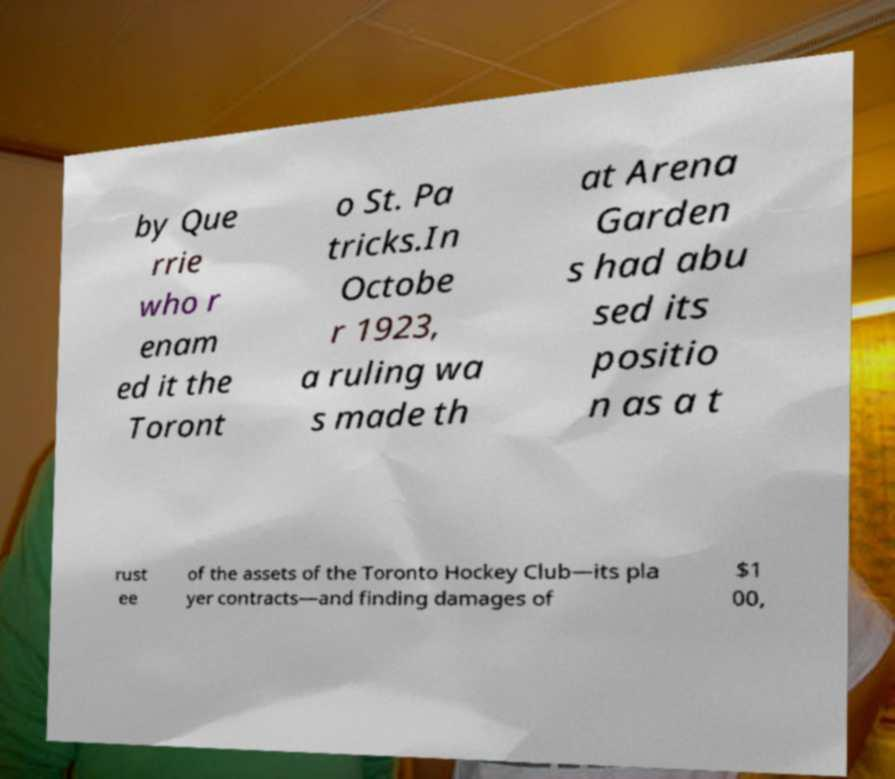What messages or text are displayed in this image? I need them in a readable, typed format. by Que rrie who r enam ed it the Toront o St. Pa tricks.In Octobe r 1923, a ruling wa s made th at Arena Garden s had abu sed its positio n as a t rust ee of the assets of the Toronto Hockey Club—its pla yer contracts—and finding damages of $1 00, 